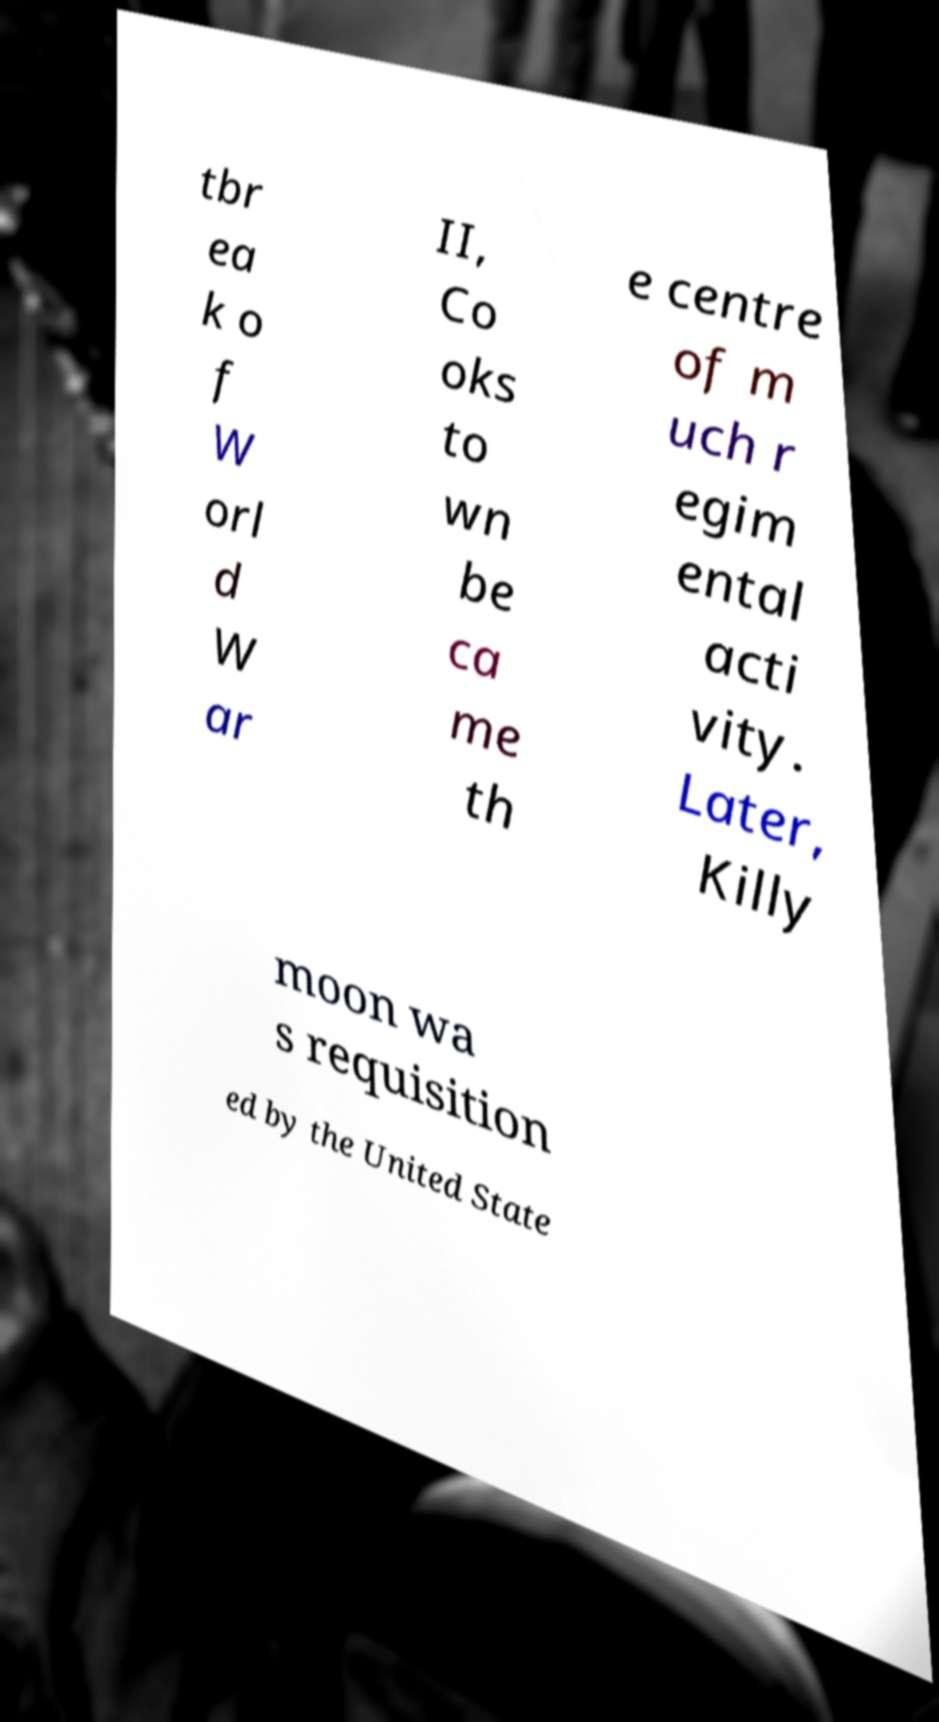I need the written content from this picture converted into text. Can you do that? tbr ea k o f W orl d W ar II, Co oks to wn be ca me th e centre of m uch r egim ental acti vity. Later, Killy moon wa s requisition ed by the United State 